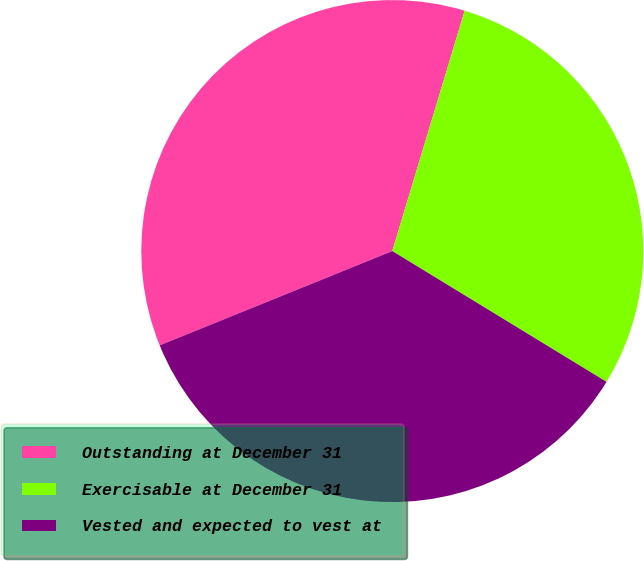<chart> <loc_0><loc_0><loc_500><loc_500><pie_chart><fcel>Outstanding at December 31<fcel>Exercisable at December 31<fcel>Vested and expected to vest at<nl><fcel>35.79%<fcel>29.07%<fcel>35.15%<nl></chart> 